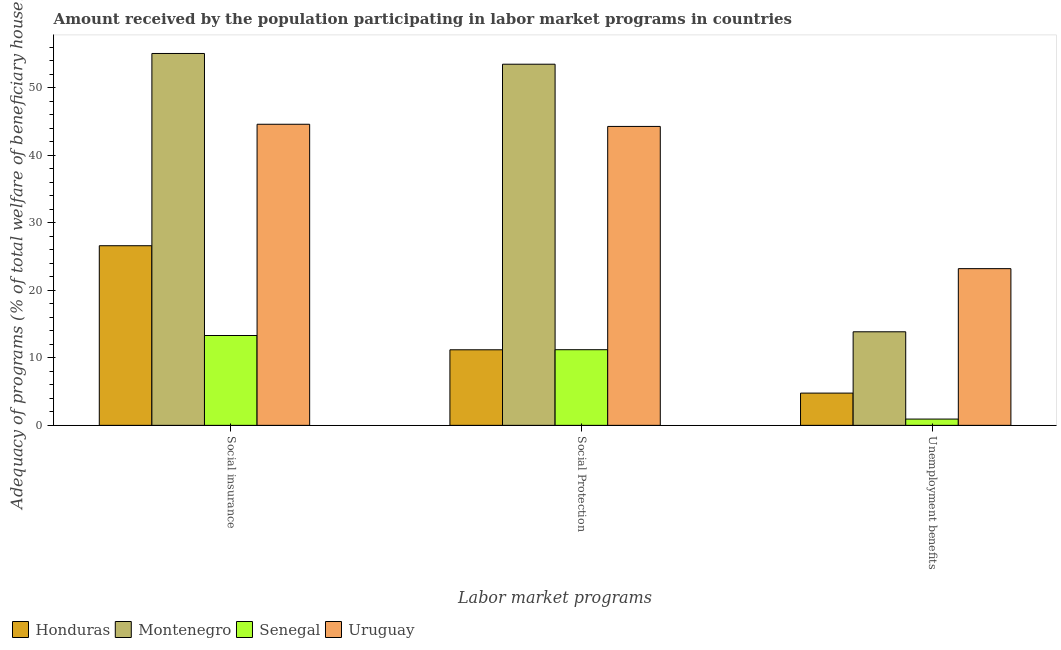How many different coloured bars are there?
Make the answer very short. 4. How many groups of bars are there?
Your answer should be compact. 3. Are the number of bars per tick equal to the number of legend labels?
Offer a terse response. Yes. How many bars are there on the 2nd tick from the left?
Provide a short and direct response. 4. How many bars are there on the 1st tick from the right?
Offer a very short reply. 4. What is the label of the 1st group of bars from the left?
Provide a succinct answer. Social insurance. What is the amount received by the population participating in social protection programs in Montenegro?
Offer a very short reply. 53.48. Across all countries, what is the maximum amount received by the population participating in unemployment benefits programs?
Provide a succinct answer. 23.2. Across all countries, what is the minimum amount received by the population participating in social insurance programs?
Offer a very short reply. 13.3. In which country was the amount received by the population participating in unemployment benefits programs maximum?
Keep it short and to the point. Uruguay. In which country was the amount received by the population participating in social insurance programs minimum?
Provide a short and direct response. Senegal. What is the total amount received by the population participating in unemployment benefits programs in the graph?
Your answer should be very brief. 42.76. What is the difference between the amount received by the population participating in social insurance programs in Honduras and that in Montenegro?
Your response must be concise. -28.47. What is the difference between the amount received by the population participating in social insurance programs in Senegal and the amount received by the population participating in unemployment benefits programs in Honduras?
Provide a succinct answer. 8.53. What is the average amount received by the population participating in social protection programs per country?
Your answer should be very brief. 30.03. What is the difference between the amount received by the population participating in social protection programs and amount received by the population participating in unemployment benefits programs in Senegal?
Keep it short and to the point. 10.27. In how many countries, is the amount received by the population participating in social insurance programs greater than 8 %?
Keep it short and to the point. 4. What is the ratio of the amount received by the population participating in unemployment benefits programs in Senegal to that in Montenegro?
Provide a succinct answer. 0.07. Is the amount received by the population participating in social protection programs in Senegal less than that in Uruguay?
Your answer should be very brief. Yes. What is the difference between the highest and the second highest amount received by the population participating in social insurance programs?
Give a very brief answer. 10.48. What is the difference between the highest and the lowest amount received by the population participating in social protection programs?
Your answer should be very brief. 42.29. Is the sum of the amount received by the population participating in social insurance programs in Uruguay and Montenegro greater than the maximum amount received by the population participating in social protection programs across all countries?
Give a very brief answer. Yes. What does the 2nd bar from the left in Unemployment benefits represents?
Offer a terse response. Montenegro. What does the 3rd bar from the right in Social insurance represents?
Your response must be concise. Montenegro. Is it the case that in every country, the sum of the amount received by the population participating in social insurance programs and amount received by the population participating in social protection programs is greater than the amount received by the population participating in unemployment benefits programs?
Keep it short and to the point. Yes. How many bars are there?
Your answer should be very brief. 12. Are all the bars in the graph horizontal?
Provide a short and direct response. No. What is the difference between two consecutive major ticks on the Y-axis?
Ensure brevity in your answer.  10. Does the graph contain grids?
Give a very brief answer. No. How are the legend labels stacked?
Make the answer very short. Horizontal. What is the title of the graph?
Your answer should be compact. Amount received by the population participating in labor market programs in countries. What is the label or title of the X-axis?
Offer a terse response. Labor market programs. What is the label or title of the Y-axis?
Your response must be concise. Adequacy of programs (% of total welfare of beneficiary households). What is the Adequacy of programs (% of total welfare of beneficiary households) of Honduras in Social insurance?
Make the answer very short. 26.6. What is the Adequacy of programs (% of total welfare of beneficiary households) of Montenegro in Social insurance?
Your response must be concise. 55.07. What is the Adequacy of programs (% of total welfare of beneficiary households) of Senegal in Social insurance?
Your response must be concise. 13.3. What is the Adequacy of programs (% of total welfare of beneficiary households) in Uruguay in Social insurance?
Your answer should be very brief. 44.58. What is the Adequacy of programs (% of total welfare of beneficiary households) of Honduras in Social Protection?
Your answer should be compact. 11.19. What is the Adequacy of programs (% of total welfare of beneficiary households) of Montenegro in Social Protection?
Make the answer very short. 53.48. What is the Adequacy of programs (% of total welfare of beneficiary households) in Senegal in Social Protection?
Your answer should be very brief. 11.2. What is the Adequacy of programs (% of total welfare of beneficiary households) of Uruguay in Social Protection?
Ensure brevity in your answer.  44.26. What is the Adequacy of programs (% of total welfare of beneficiary households) of Honduras in Unemployment benefits?
Provide a short and direct response. 4.77. What is the Adequacy of programs (% of total welfare of beneficiary households) of Montenegro in Unemployment benefits?
Your answer should be compact. 13.85. What is the Adequacy of programs (% of total welfare of beneficiary households) in Senegal in Unemployment benefits?
Provide a succinct answer. 0.93. What is the Adequacy of programs (% of total welfare of beneficiary households) in Uruguay in Unemployment benefits?
Offer a very short reply. 23.2. Across all Labor market programs, what is the maximum Adequacy of programs (% of total welfare of beneficiary households) of Honduras?
Make the answer very short. 26.6. Across all Labor market programs, what is the maximum Adequacy of programs (% of total welfare of beneficiary households) of Montenegro?
Offer a terse response. 55.07. Across all Labor market programs, what is the maximum Adequacy of programs (% of total welfare of beneficiary households) in Senegal?
Give a very brief answer. 13.3. Across all Labor market programs, what is the maximum Adequacy of programs (% of total welfare of beneficiary households) in Uruguay?
Your answer should be compact. 44.58. Across all Labor market programs, what is the minimum Adequacy of programs (% of total welfare of beneficiary households) in Honduras?
Ensure brevity in your answer.  4.77. Across all Labor market programs, what is the minimum Adequacy of programs (% of total welfare of beneficiary households) of Montenegro?
Your response must be concise. 13.85. Across all Labor market programs, what is the minimum Adequacy of programs (% of total welfare of beneficiary households) in Senegal?
Provide a short and direct response. 0.93. Across all Labor market programs, what is the minimum Adequacy of programs (% of total welfare of beneficiary households) of Uruguay?
Provide a succinct answer. 23.2. What is the total Adequacy of programs (% of total welfare of beneficiary households) of Honduras in the graph?
Your response must be concise. 42.56. What is the total Adequacy of programs (% of total welfare of beneficiary households) in Montenegro in the graph?
Your answer should be very brief. 122.4. What is the total Adequacy of programs (% of total welfare of beneficiary households) in Senegal in the graph?
Give a very brief answer. 25.43. What is the total Adequacy of programs (% of total welfare of beneficiary households) of Uruguay in the graph?
Offer a very short reply. 112.05. What is the difference between the Adequacy of programs (% of total welfare of beneficiary households) in Honduras in Social insurance and that in Social Protection?
Provide a short and direct response. 15.41. What is the difference between the Adequacy of programs (% of total welfare of beneficiary households) of Montenegro in Social insurance and that in Social Protection?
Your answer should be compact. 1.59. What is the difference between the Adequacy of programs (% of total welfare of beneficiary households) of Senegal in Social insurance and that in Social Protection?
Give a very brief answer. 2.1. What is the difference between the Adequacy of programs (% of total welfare of beneficiary households) in Uruguay in Social insurance and that in Social Protection?
Make the answer very short. 0.32. What is the difference between the Adequacy of programs (% of total welfare of beneficiary households) in Honduras in Social insurance and that in Unemployment benefits?
Offer a terse response. 21.82. What is the difference between the Adequacy of programs (% of total welfare of beneficiary households) of Montenegro in Social insurance and that in Unemployment benefits?
Ensure brevity in your answer.  41.21. What is the difference between the Adequacy of programs (% of total welfare of beneficiary households) of Senegal in Social insurance and that in Unemployment benefits?
Ensure brevity in your answer.  12.37. What is the difference between the Adequacy of programs (% of total welfare of beneficiary households) of Uruguay in Social insurance and that in Unemployment benefits?
Your answer should be very brief. 21.38. What is the difference between the Adequacy of programs (% of total welfare of beneficiary households) in Honduras in Social Protection and that in Unemployment benefits?
Offer a terse response. 6.41. What is the difference between the Adequacy of programs (% of total welfare of beneficiary households) in Montenegro in Social Protection and that in Unemployment benefits?
Your answer should be compact. 39.62. What is the difference between the Adequacy of programs (% of total welfare of beneficiary households) of Senegal in Social Protection and that in Unemployment benefits?
Provide a short and direct response. 10.27. What is the difference between the Adequacy of programs (% of total welfare of beneficiary households) in Uruguay in Social Protection and that in Unemployment benefits?
Your answer should be compact. 21.06. What is the difference between the Adequacy of programs (% of total welfare of beneficiary households) in Honduras in Social insurance and the Adequacy of programs (% of total welfare of beneficiary households) in Montenegro in Social Protection?
Make the answer very short. -26.88. What is the difference between the Adequacy of programs (% of total welfare of beneficiary households) in Honduras in Social insurance and the Adequacy of programs (% of total welfare of beneficiary households) in Senegal in Social Protection?
Provide a succinct answer. 15.4. What is the difference between the Adequacy of programs (% of total welfare of beneficiary households) in Honduras in Social insurance and the Adequacy of programs (% of total welfare of beneficiary households) in Uruguay in Social Protection?
Make the answer very short. -17.66. What is the difference between the Adequacy of programs (% of total welfare of beneficiary households) in Montenegro in Social insurance and the Adequacy of programs (% of total welfare of beneficiary households) in Senegal in Social Protection?
Ensure brevity in your answer.  43.87. What is the difference between the Adequacy of programs (% of total welfare of beneficiary households) in Montenegro in Social insurance and the Adequacy of programs (% of total welfare of beneficiary households) in Uruguay in Social Protection?
Make the answer very short. 10.8. What is the difference between the Adequacy of programs (% of total welfare of beneficiary households) in Senegal in Social insurance and the Adequacy of programs (% of total welfare of beneficiary households) in Uruguay in Social Protection?
Your answer should be compact. -30.96. What is the difference between the Adequacy of programs (% of total welfare of beneficiary households) of Honduras in Social insurance and the Adequacy of programs (% of total welfare of beneficiary households) of Montenegro in Unemployment benefits?
Your answer should be compact. 12.74. What is the difference between the Adequacy of programs (% of total welfare of beneficiary households) in Honduras in Social insurance and the Adequacy of programs (% of total welfare of beneficiary households) in Senegal in Unemployment benefits?
Give a very brief answer. 25.67. What is the difference between the Adequacy of programs (% of total welfare of beneficiary households) in Honduras in Social insurance and the Adequacy of programs (% of total welfare of beneficiary households) in Uruguay in Unemployment benefits?
Ensure brevity in your answer.  3.39. What is the difference between the Adequacy of programs (% of total welfare of beneficiary households) of Montenegro in Social insurance and the Adequacy of programs (% of total welfare of beneficiary households) of Senegal in Unemployment benefits?
Ensure brevity in your answer.  54.14. What is the difference between the Adequacy of programs (% of total welfare of beneficiary households) in Montenegro in Social insurance and the Adequacy of programs (% of total welfare of beneficiary households) in Uruguay in Unemployment benefits?
Keep it short and to the point. 31.86. What is the difference between the Adequacy of programs (% of total welfare of beneficiary households) in Senegal in Social insurance and the Adequacy of programs (% of total welfare of beneficiary households) in Uruguay in Unemployment benefits?
Your answer should be compact. -9.9. What is the difference between the Adequacy of programs (% of total welfare of beneficiary households) in Honduras in Social Protection and the Adequacy of programs (% of total welfare of beneficiary households) in Montenegro in Unemployment benefits?
Your answer should be compact. -2.67. What is the difference between the Adequacy of programs (% of total welfare of beneficiary households) in Honduras in Social Protection and the Adequacy of programs (% of total welfare of beneficiary households) in Senegal in Unemployment benefits?
Your answer should be compact. 10.26. What is the difference between the Adequacy of programs (% of total welfare of beneficiary households) in Honduras in Social Protection and the Adequacy of programs (% of total welfare of beneficiary households) in Uruguay in Unemployment benefits?
Provide a succinct answer. -12.01. What is the difference between the Adequacy of programs (% of total welfare of beneficiary households) of Montenegro in Social Protection and the Adequacy of programs (% of total welfare of beneficiary households) of Senegal in Unemployment benefits?
Offer a very short reply. 52.55. What is the difference between the Adequacy of programs (% of total welfare of beneficiary households) in Montenegro in Social Protection and the Adequacy of programs (% of total welfare of beneficiary households) in Uruguay in Unemployment benefits?
Your answer should be very brief. 30.27. What is the difference between the Adequacy of programs (% of total welfare of beneficiary households) in Senegal in Social Protection and the Adequacy of programs (% of total welfare of beneficiary households) in Uruguay in Unemployment benefits?
Make the answer very short. -12. What is the average Adequacy of programs (% of total welfare of beneficiary households) in Honduras per Labor market programs?
Your answer should be very brief. 14.19. What is the average Adequacy of programs (% of total welfare of beneficiary households) of Montenegro per Labor market programs?
Keep it short and to the point. 40.8. What is the average Adequacy of programs (% of total welfare of beneficiary households) in Senegal per Labor market programs?
Offer a terse response. 8.48. What is the average Adequacy of programs (% of total welfare of beneficiary households) in Uruguay per Labor market programs?
Offer a very short reply. 37.35. What is the difference between the Adequacy of programs (% of total welfare of beneficiary households) of Honduras and Adequacy of programs (% of total welfare of beneficiary households) of Montenegro in Social insurance?
Offer a terse response. -28.47. What is the difference between the Adequacy of programs (% of total welfare of beneficiary households) in Honduras and Adequacy of programs (% of total welfare of beneficiary households) in Senegal in Social insurance?
Offer a terse response. 13.29. What is the difference between the Adequacy of programs (% of total welfare of beneficiary households) in Honduras and Adequacy of programs (% of total welfare of beneficiary households) in Uruguay in Social insurance?
Your answer should be very brief. -17.98. What is the difference between the Adequacy of programs (% of total welfare of beneficiary households) of Montenegro and Adequacy of programs (% of total welfare of beneficiary households) of Senegal in Social insurance?
Provide a succinct answer. 41.76. What is the difference between the Adequacy of programs (% of total welfare of beneficiary households) of Montenegro and Adequacy of programs (% of total welfare of beneficiary households) of Uruguay in Social insurance?
Keep it short and to the point. 10.48. What is the difference between the Adequacy of programs (% of total welfare of beneficiary households) of Senegal and Adequacy of programs (% of total welfare of beneficiary households) of Uruguay in Social insurance?
Offer a terse response. -31.28. What is the difference between the Adequacy of programs (% of total welfare of beneficiary households) in Honduras and Adequacy of programs (% of total welfare of beneficiary households) in Montenegro in Social Protection?
Offer a terse response. -42.29. What is the difference between the Adequacy of programs (% of total welfare of beneficiary households) of Honduras and Adequacy of programs (% of total welfare of beneficiary households) of Senegal in Social Protection?
Your answer should be very brief. -0.01. What is the difference between the Adequacy of programs (% of total welfare of beneficiary households) in Honduras and Adequacy of programs (% of total welfare of beneficiary households) in Uruguay in Social Protection?
Make the answer very short. -33.07. What is the difference between the Adequacy of programs (% of total welfare of beneficiary households) of Montenegro and Adequacy of programs (% of total welfare of beneficiary households) of Senegal in Social Protection?
Your response must be concise. 42.28. What is the difference between the Adequacy of programs (% of total welfare of beneficiary households) in Montenegro and Adequacy of programs (% of total welfare of beneficiary households) in Uruguay in Social Protection?
Give a very brief answer. 9.21. What is the difference between the Adequacy of programs (% of total welfare of beneficiary households) in Senegal and Adequacy of programs (% of total welfare of beneficiary households) in Uruguay in Social Protection?
Give a very brief answer. -33.06. What is the difference between the Adequacy of programs (% of total welfare of beneficiary households) in Honduras and Adequacy of programs (% of total welfare of beneficiary households) in Montenegro in Unemployment benefits?
Your answer should be very brief. -9.08. What is the difference between the Adequacy of programs (% of total welfare of beneficiary households) in Honduras and Adequacy of programs (% of total welfare of beneficiary households) in Senegal in Unemployment benefits?
Your answer should be compact. 3.84. What is the difference between the Adequacy of programs (% of total welfare of beneficiary households) of Honduras and Adequacy of programs (% of total welfare of beneficiary households) of Uruguay in Unemployment benefits?
Make the answer very short. -18.43. What is the difference between the Adequacy of programs (% of total welfare of beneficiary households) in Montenegro and Adequacy of programs (% of total welfare of beneficiary households) in Senegal in Unemployment benefits?
Give a very brief answer. 12.92. What is the difference between the Adequacy of programs (% of total welfare of beneficiary households) in Montenegro and Adequacy of programs (% of total welfare of beneficiary households) in Uruguay in Unemployment benefits?
Offer a terse response. -9.35. What is the difference between the Adequacy of programs (% of total welfare of beneficiary households) in Senegal and Adequacy of programs (% of total welfare of beneficiary households) in Uruguay in Unemployment benefits?
Make the answer very short. -22.27. What is the ratio of the Adequacy of programs (% of total welfare of beneficiary households) in Honduras in Social insurance to that in Social Protection?
Give a very brief answer. 2.38. What is the ratio of the Adequacy of programs (% of total welfare of beneficiary households) of Montenegro in Social insurance to that in Social Protection?
Keep it short and to the point. 1.03. What is the ratio of the Adequacy of programs (% of total welfare of beneficiary households) in Senegal in Social insurance to that in Social Protection?
Provide a short and direct response. 1.19. What is the ratio of the Adequacy of programs (% of total welfare of beneficiary households) of Uruguay in Social insurance to that in Social Protection?
Give a very brief answer. 1.01. What is the ratio of the Adequacy of programs (% of total welfare of beneficiary households) in Honduras in Social insurance to that in Unemployment benefits?
Provide a succinct answer. 5.57. What is the ratio of the Adequacy of programs (% of total welfare of beneficiary households) in Montenegro in Social insurance to that in Unemployment benefits?
Offer a terse response. 3.97. What is the ratio of the Adequacy of programs (% of total welfare of beneficiary households) in Senegal in Social insurance to that in Unemployment benefits?
Your response must be concise. 14.3. What is the ratio of the Adequacy of programs (% of total welfare of beneficiary households) of Uruguay in Social insurance to that in Unemployment benefits?
Your answer should be compact. 1.92. What is the ratio of the Adequacy of programs (% of total welfare of beneficiary households) in Honduras in Social Protection to that in Unemployment benefits?
Provide a succinct answer. 2.34. What is the ratio of the Adequacy of programs (% of total welfare of beneficiary households) of Montenegro in Social Protection to that in Unemployment benefits?
Keep it short and to the point. 3.86. What is the ratio of the Adequacy of programs (% of total welfare of beneficiary households) of Senegal in Social Protection to that in Unemployment benefits?
Give a very brief answer. 12.04. What is the ratio of the Adequacy of programs (% of total welfare of beneficiary households) in Uruguay in Social Protection to that in Unemployment benefits?
Make the answer very short. 1.91. What is the difference between the highest and the second highest Adequacy of programs (% of total welfare of beneficiary households) in Honduras?
Your answer should be compact. 15.41. What is the difference between the highest and the second highest Adequacy of programs (% of total welfare of beneficiary households) of Montenegro?
Your answer should be compact. 1.59. What is the difference between the highest and the second highest Adequacy of programs (% of total welfare of beneficiary households) of Senegal?
Your answer should be compact. 2.1. What is the difference between the highest and the second highest Adequacy of programs (% of total welfare of beneficiary households) of Uruguay?
Provide a short and direct response. 0.32. What is the difference between the highest and the lowest Adequacy of programs (% of total welfare of beneficiary households) of Honduras?
Offer a terse response. 21.82. What is the difference between the highest and the lowest Adequacy of programs (% of total welfare of beneficiary households) of Montenegro?
Keep it short and to the point. 41.21. What is the difference between the highest and the lowest Adequacy of programs (% of total welfare of beneficiary households) in Senegal?
Offer a terse response. 12.37. What is the difference between the highest and the lowest Adequacy of programs (% of total welfare of beneficiary households) of Uruguay?
Make the answer very short. 21.38. 